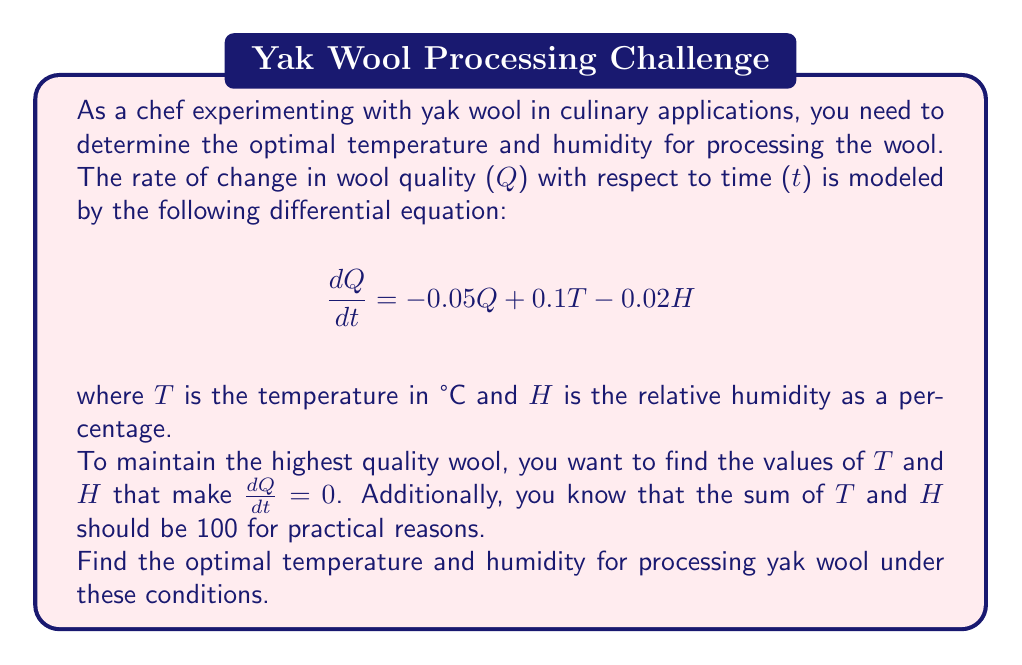Provide a solution to this math problem. Let's approach this problem step-by-step:

1) We want to find the values of $T$ and $H$ that make $\frac{dQ}{dt} = 0$. So, we set up the equation:

   $$0 = -0.05Q + 0.1T - 0.02H$$

2) We also know that $T + H = 100$. We can use this to express $H$ in terms of $T$:

   $$H = 100 - T$$

3) Substituting this into our first equation:

   $$0 = -0.05Q + 0.1T - 0.02(100 - T)$$

4) Simplify:

   $$0 = -0.05Q + 0.1T - 2 + 0.02T$$
   $$0 = -0.05Q + 0.12T - 2$$

5) We're interested in the steady state where quality doesn't change, so $Q$ doesn't matter for finding the optimal $T$ and $H$. We can solve for $T$:

   $$0.12T = 2$$
   $$T = \frac{2}{0.12} = 16.67$$

6) Round to the nearest whole number:

   $$T = 17°C$$

7) Now we can find $H$ using $H = 100 - T$:

   $$H = 100 - 17 = 83\%$$

Therefore, the optimal temperature is 17°C and the optimal humidity is 83%.
Answer: The optimal temperature for processing yak wool is 17°C and the optimal humidity is 83%. 